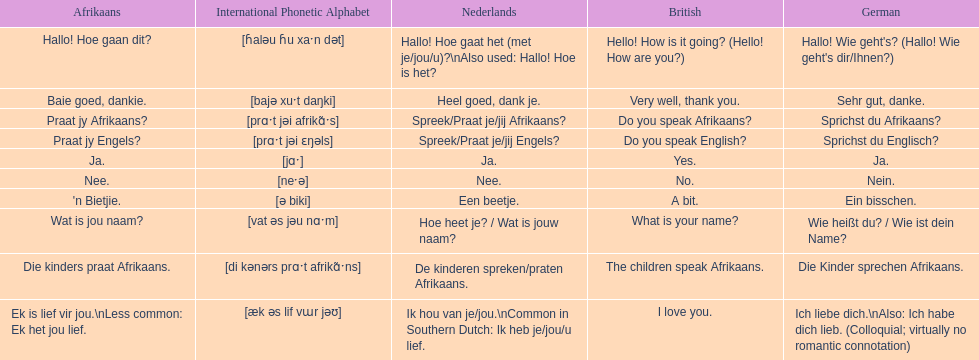How do you say 'do you speak afrikaans?' in afrikaans? Praat jy Afrikaans?. 